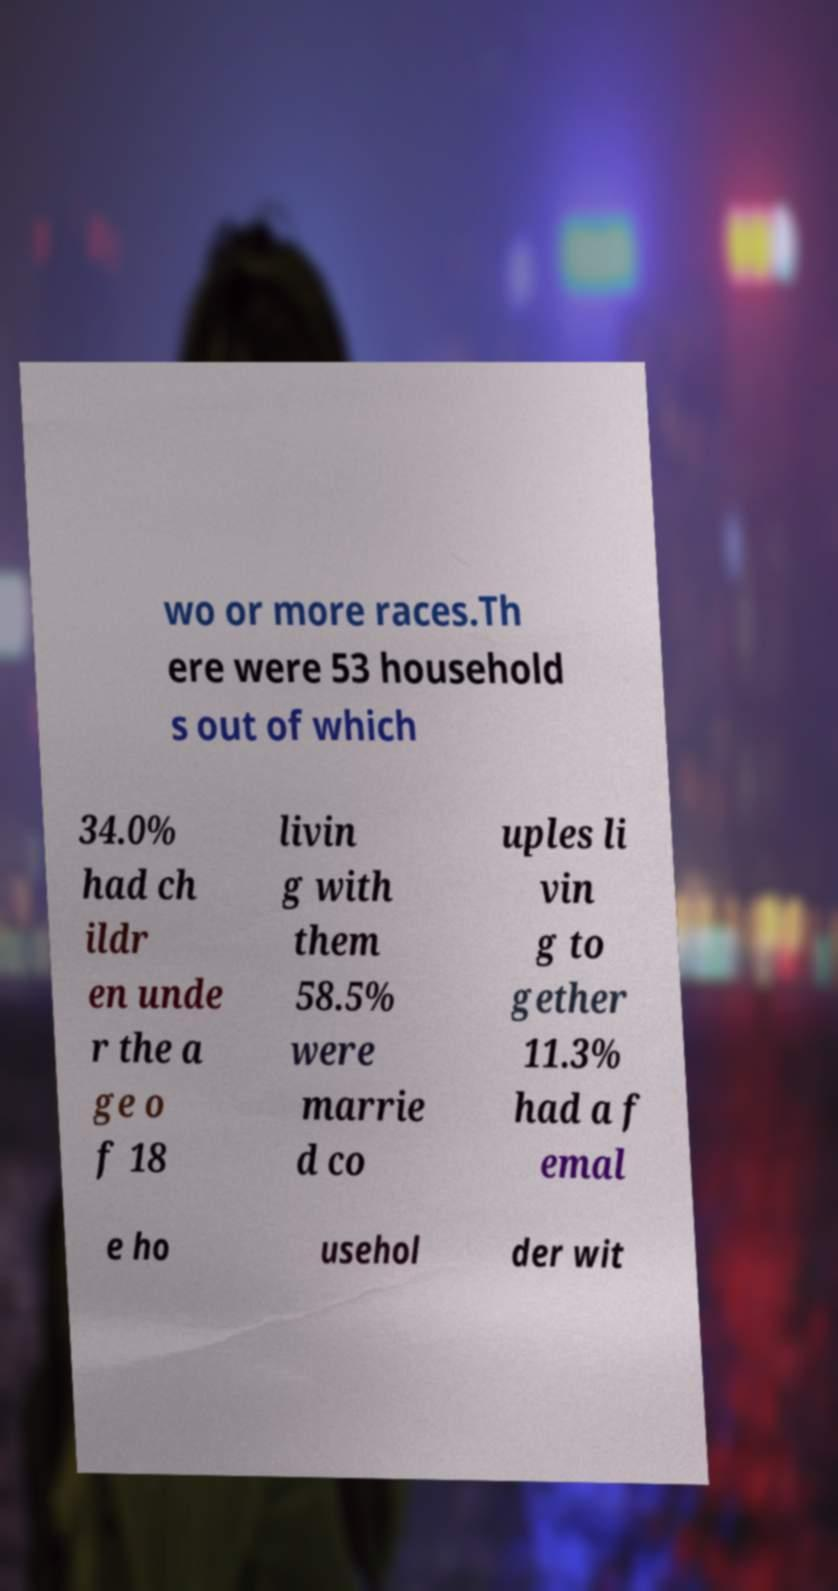There's text embedded in this image that I need extracted. Can you transcribe it verbatim? wo or more races.Th ere were 53 household s out of which 34.0% had ch ildr en unde r the a ge o f 18 livin g with them 58.5% were marrie d co uples li vin g to gether 11.3% had a f emal e ho usehol der wit 